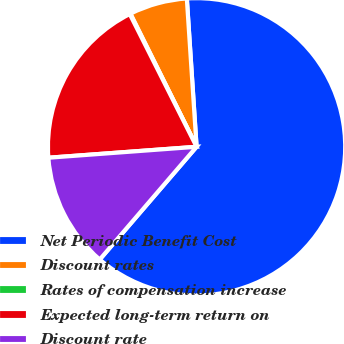<chart> <loc_0><loc_0><loc_500><loc_500><pie_chart><fcel>Net Periodic Benefit Cost<fcel>Discount rates<fcel>Rates of compensation increase<fcel>Expected long-term return on<fcel>Discount rate<nl><fcel>62.34%<fcel>6.3%<fcel>0.08%<fcel>18.75%<fcel>12.53%<nl></chart> 